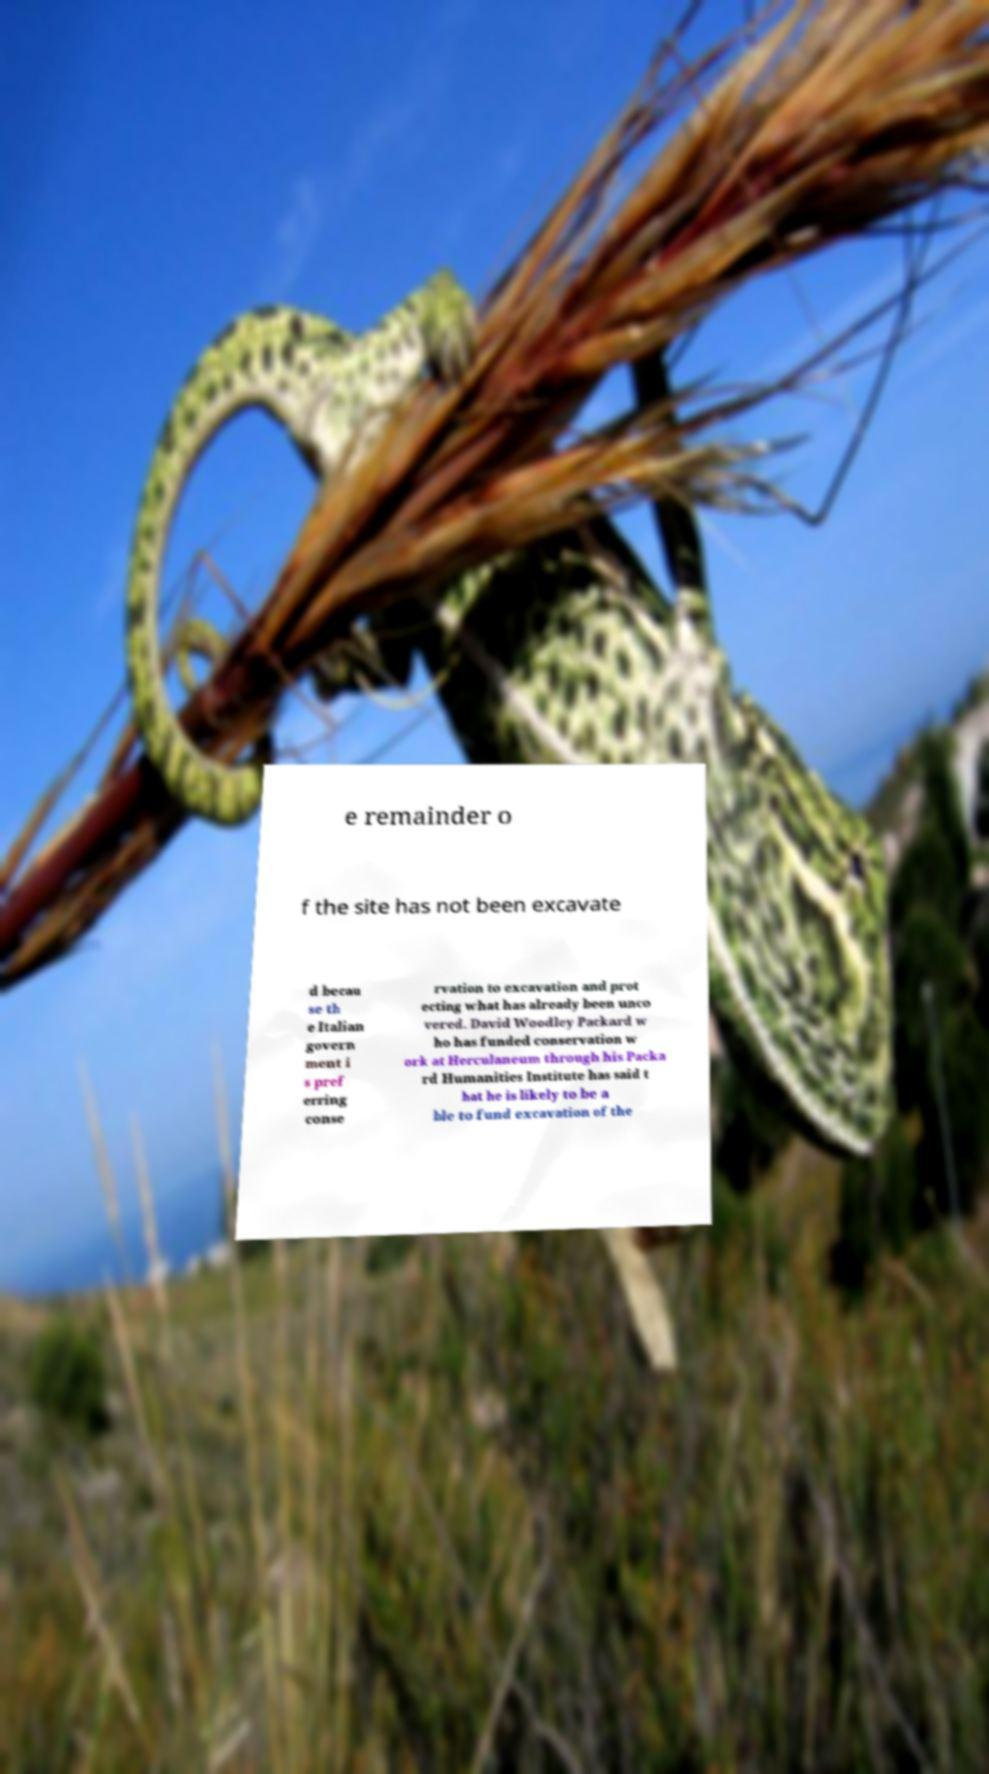Could you extract and type out the text from this image? e remainder o f the site has not been excavate d becau se th e Italian govern ment i s pref erring conse rvation to excavation and prot ecting what has already been unco vered. David Woodley Packard w ho has funded conservation w ork at Herculaneum through his Packa rd Humanities Institute has said t hat he is likely to be a ble to fund excavation of the 